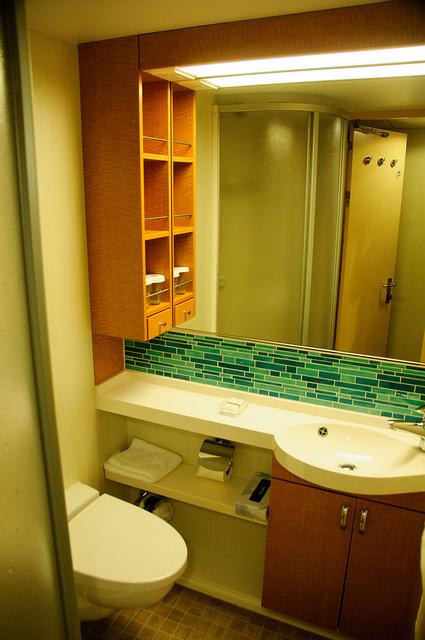Is this a bathroom?
Quick response, please. Yes. How many drawers are in the wall cabinet?
Answer briefly. 2. What are the green tiles made of?
Quick response, please. Glass. 